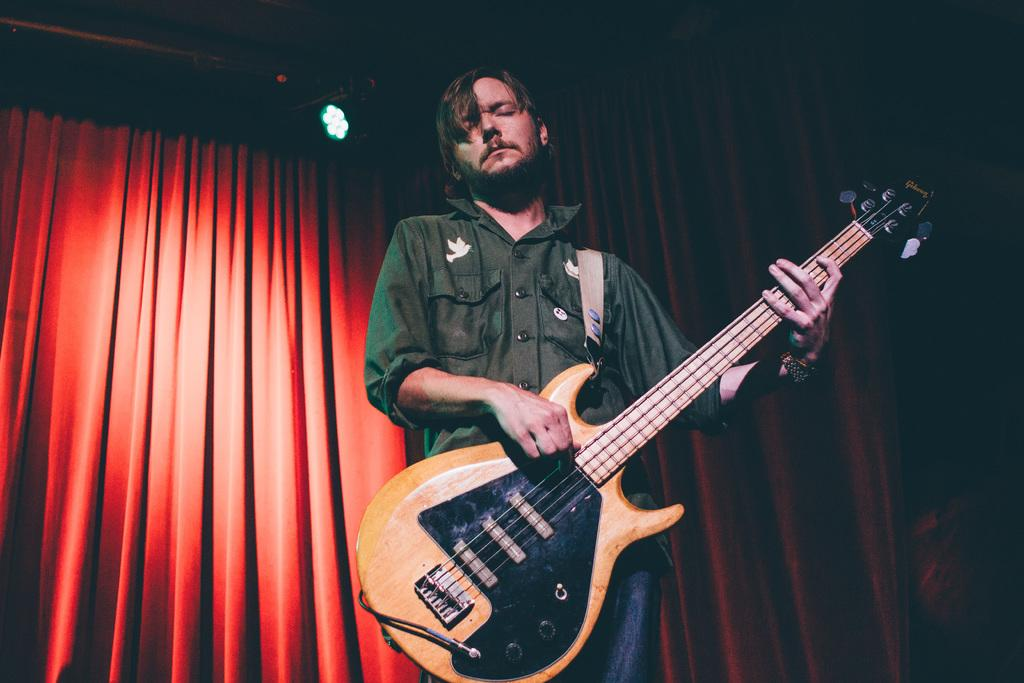What is the man in the image doing? The man is playing a guitar in the image. What is the man wearing in the image? The man is wearing a green shirt in the image. What can be seen in the background of the image? There is a red curtain in the background of the image. What type of insect is crawling on the man's guitar in the image? There is no insect present on the man's guitar in the image. Is the man's manager in the image? There is no mention of a manager in the image, and no one else is visible besides the man playing the guitar. 